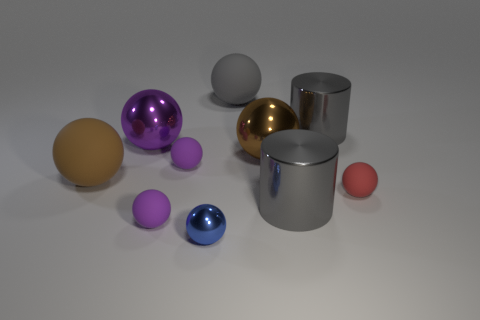How many brown balls must be subtracted to get 1 brown balls? 1 Subtract all gray cylinders. How many purple spheres are left? 3 Subtract all large rubber spheres. How many spheres are left? 6 Subtract all red balls. How many balls are left? 7 Subtract 3 spheres. How many spheres are left? 5 Subtract all blue balls. Subtract all brown blocks. How many balls are left? 7 Subtract all balls. How many objects are left? 2 Subtract all big purple things. Subtract all big brown shiny objects. How many objects are left? 8 Add 3 blue shiny things. How many blue shiny things are left? 4 Add 7 big purple cylinders. How many big purple cylinders exist? 7 